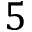Convert formula to latex. <formula><loc_0><loc_0><loc_500><loc_500>5</formula> 